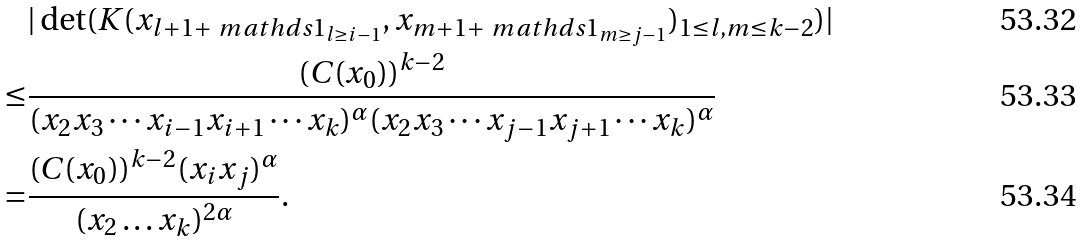Convert formula to latex. <formula><loc_0><loc_0><loc_500><loc_500>& | \det ( K ( x _ { l + 1 + \ m a t h d s { 1 } _ { l \geq i - 1 } } , x _ { m + 1 + \ m a t h d s { 1 } _ { m \geq j - 1 } } ) _ { 1 \leq l , m \leq k - 2 } ) | \\ \leq & \frac { ( C ( x _ { 0 } ) ) ^ { k - 2 } } { ( x _ { 2 } x _ { 3 } \cdots x _ { i - 1 } x _ { i + 1 } \cdots x _ { k } ) ^ { \alpha } ( x _ { 2 } x _ { 3 } \cdots x _ { j - 1 } x _ { j + 1 } \cdots x _ { k } ) ^ { \alpha } } \\ = & \frac { ( C ( x _ { 0 } ) ) ^ { k - 2 } ( x _ { i } x _ { j } ) ^ { \alpha } } { ( x _ { 2 } \dots x _ { k } ) ^ { 2 \alpha } } .</formula> 